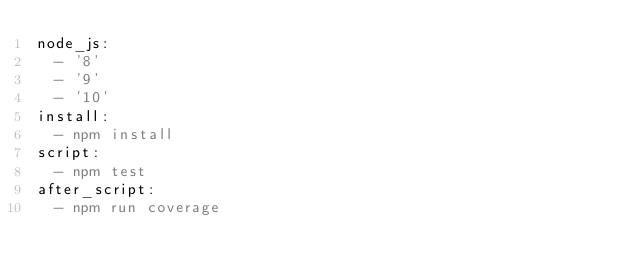<code> <loc_0><loc_0><loc_500><loc_500><_YAML_>node_js:
  - '8'
  - '9'
  - '10'
install:
  - npm install
script:
  - npm test
after_script:
  - npm run coverage
</code> 